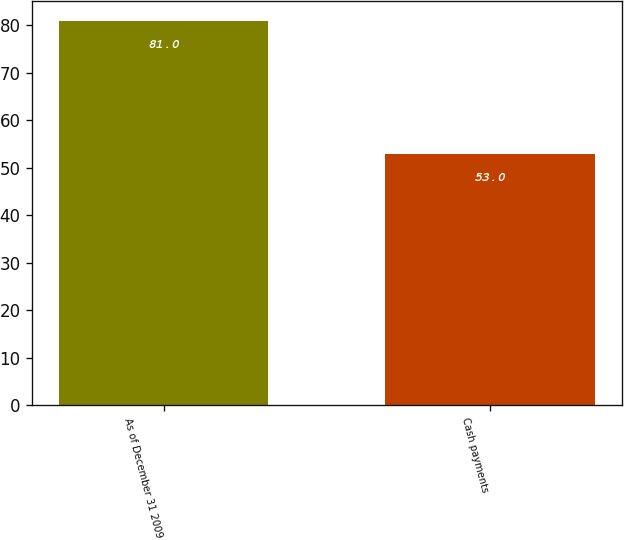<chart> <loc_0><loc_0><loc_500><loc_500><bar_chart><fcel>As of December 31 2009<fcel>Cash payments<nl><fcel>81<fcel>53<nl></chart> 